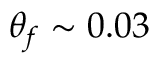Convert formula to latex. <formula><loc_0><loc_0><loc_500><loc_500>\theta _ { f } \sim 0 . 0 3</formula> 